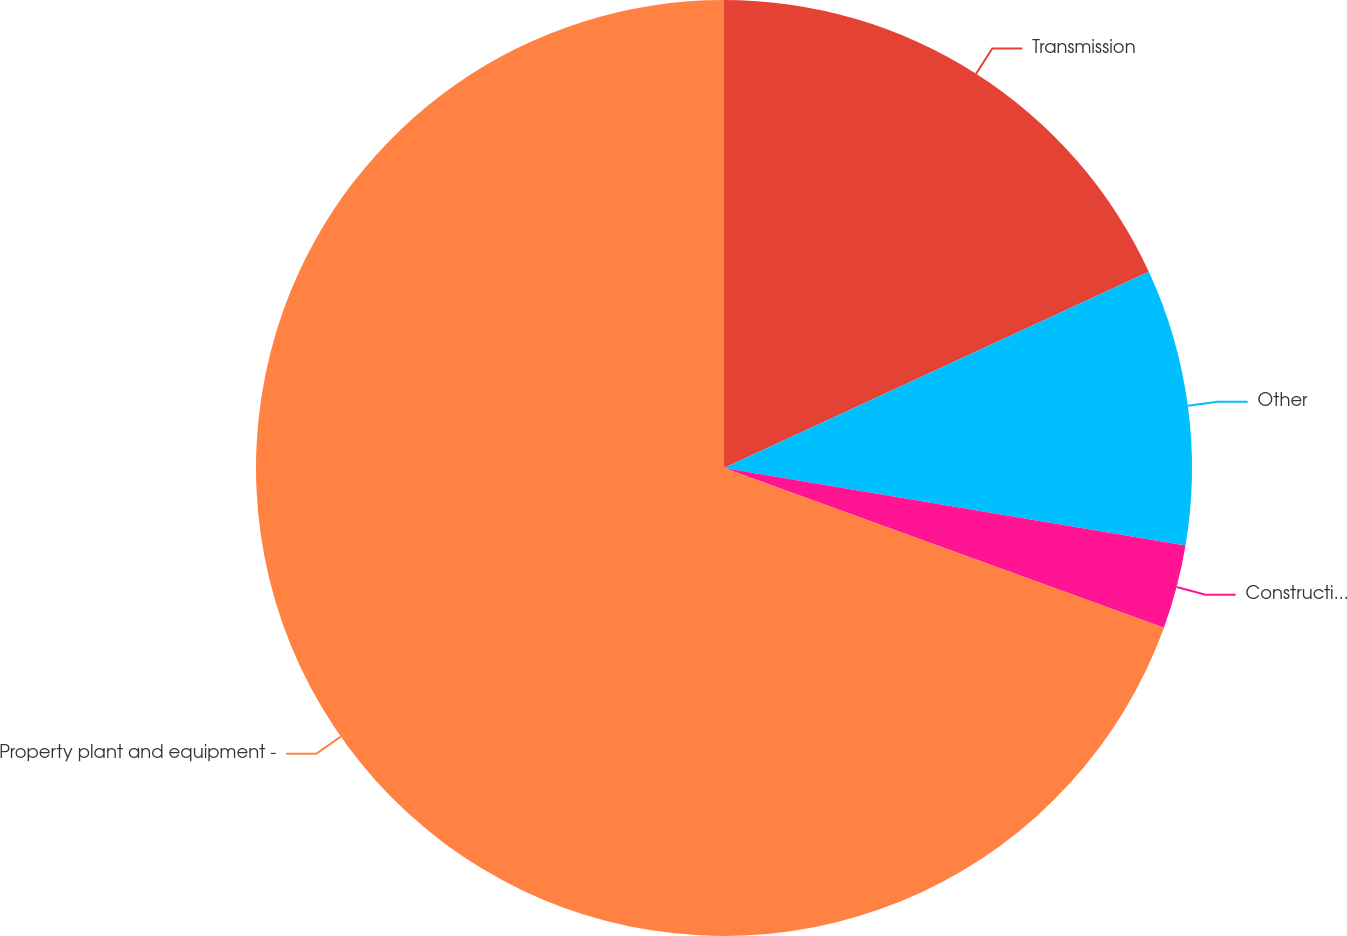Convert chart to OTSL. <chart><loc_0><loc_0><loc_500><loc_500><pie_chart><fcel>Transmission<fcel>Other<fcel>Construction work in progress<fcel>Property plant and equipment -<nl><fcel>18.11%<fcel>9.54%<fcel>2.89%<fcel>69.46%<nl></chart> 